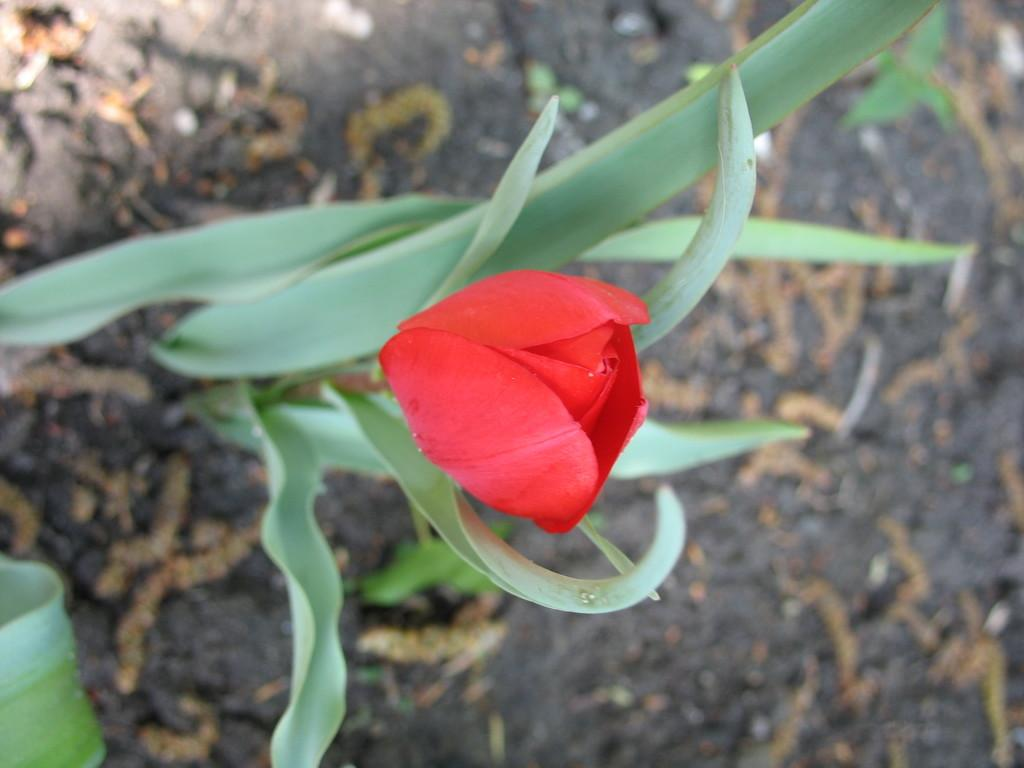What is the main subject of the image? There is a flower in the image. Is the flower part of a larger plant? Yes, the flower is accompanied by a plant. What part of the plant can be seen at the bottom of the image? A leaf is visible at the bottom of the image. What type of surface is visible in the background of the image? The background of the image includes the ground. What type of receipt is visible in the image? There is no receipt present in the image. How many sisters are shown interacting with the flower in the image? There are no people, including sisters, present in the image. 